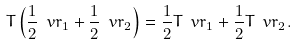Convert formula to latex. <formula><loc_0><loc_0><loc_500><loc_500>T \left ( \frac { 1 } { 2 } \ v r _ { 1 } + \frac { 1 } { 2 } \ v r _ { 2 } \right ) = \frac { 1 } { 2 } T \ v r _ { 1 } + \frac { 1 } { 2 } T \ v r _ { 2 } .</formula> 